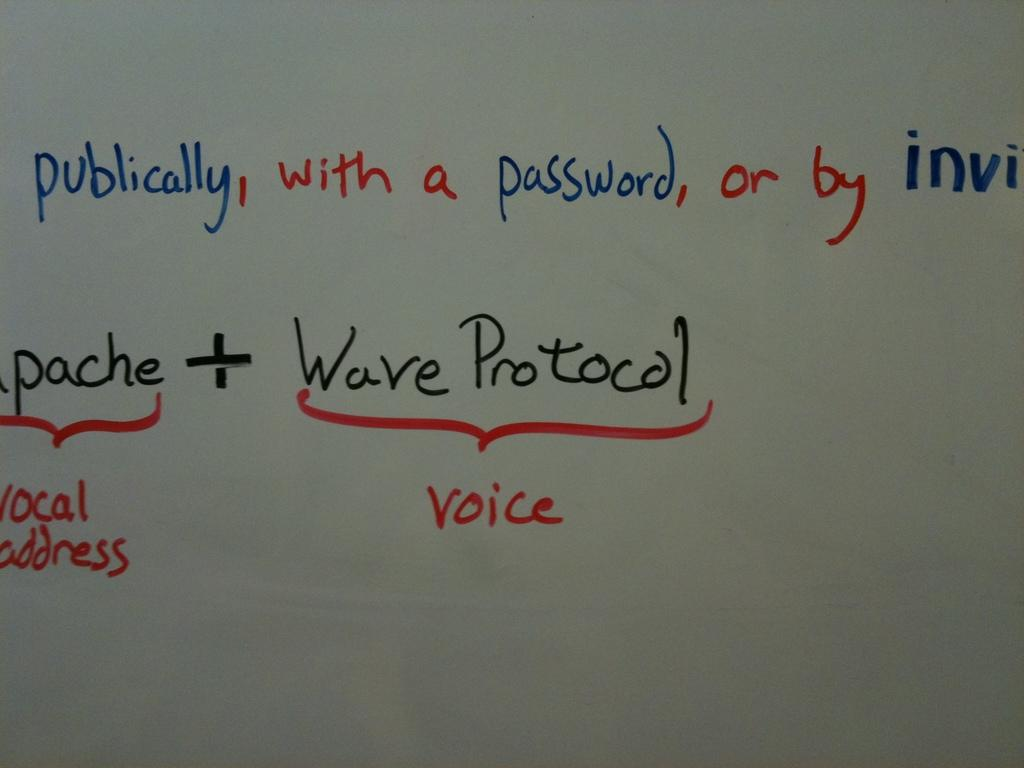<image>
Summarize the visual content of the image. The writing in black with red under it says Wave Protocol 